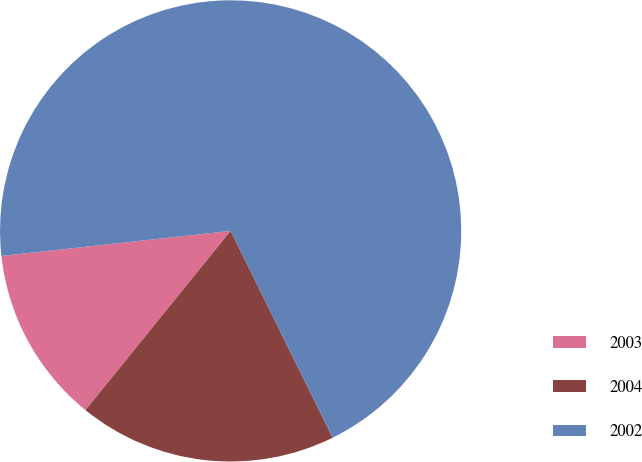<chart> <loc_0><loc_0><loc_500><loc_500><pie_chart><fcel>2003<fcel>2004<fcel>2002<nl><fcel>12.43%<fcel>18.13%<fcel>69.44%<nl></chart> 